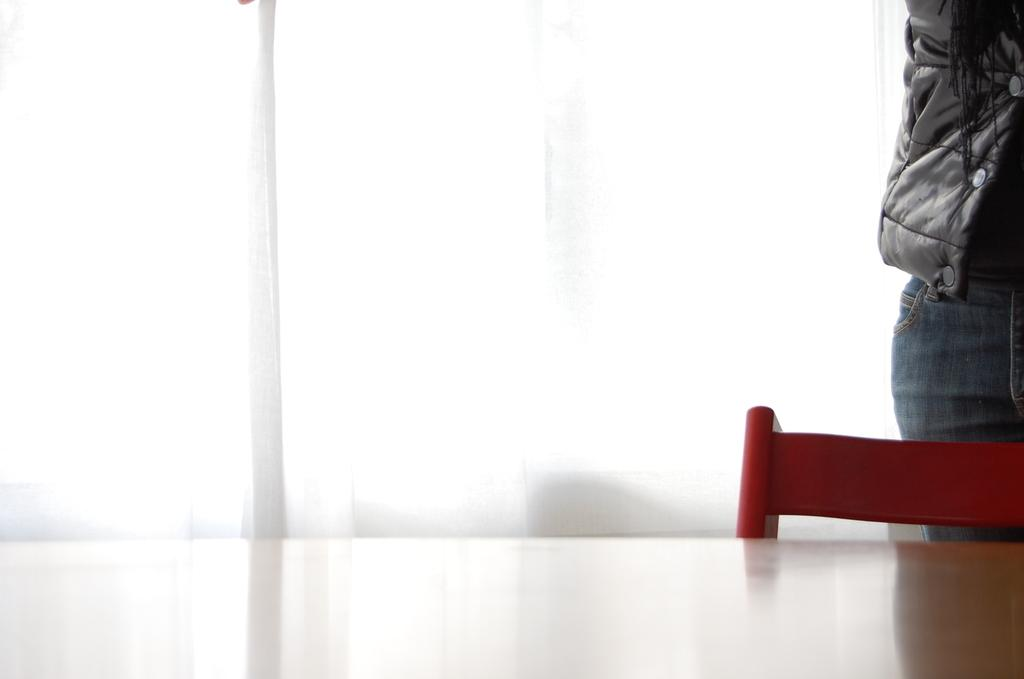What type of furniture is present at the bottom of the image? There is a table and a chair in the image. Where is the person located in the image? The person is on the right side of the image. What can be seen in the background of the image? There is a curtain in the background of the image. What type of yarn is being used to create the sofa in the image? There is no sofa present in the image, so there is no yarn being used to create it. What is the weather like in the image? The provided facts do not mention the weather, so it cannot be determined from the image. 